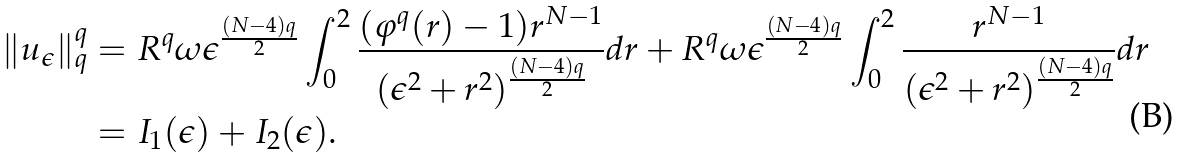<formula> <loc_0><loc_0><loc_500><loc_500>\| u _ { \epsilon } \| _ { q } ^ { q } & = R ^ { q } \omega \epsilon ^ { \frac { ( N - 4 ) q } { 2 } } \int _ { 0 } ^ { 2 } \frac { ( \varphi ^ { q } ( r ) - 1 ) r ^ { N - 1 } } { ( \epsilon ^ { 2 } + r ^ { 2 } ) ^ { \frac { ( N - 4 ) q } { 2 } } } d r + R ^ { q } \omega \epsilon ^ { \frac { ( N - 4 ) q } { 2 } } \int _ { 0 } ^ { 2 } \frac { r ^ { N - 1 } } { ( \epsilon ^ { 2 } + r ^ { 2 } ) ^ { \frac { ( N - 4 ) q } { 2 } } } d r \\ & = I _ { 1 } ( \epsilon ) + I _ { 2 } ( \epsilon ) . \\</formula> 